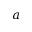Convert formula to latex. <formula><loc_0><loc_0><loc_500><loc_500>a</formula> 